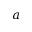Convert formula to latex. <formula><loc_0><loc_0><loc_500><loc_500>a</formula> 